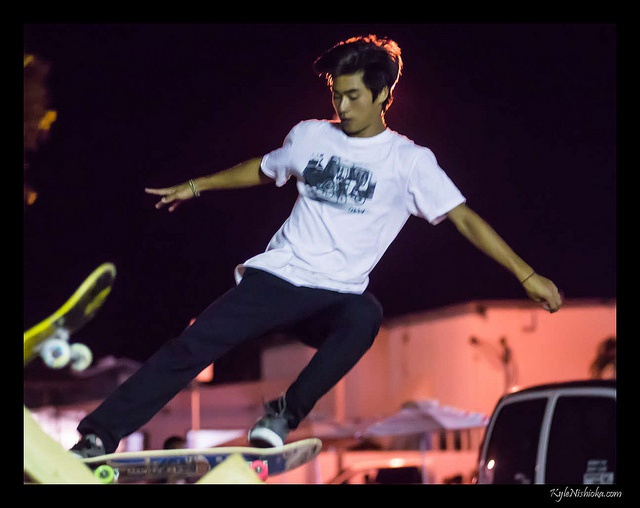Describe the objects in this image and their specific colors. I can see people in black, lavender, brown, and gray tones, car in black, gray, and maroon tones, skateboard in black, gray, darkgray, beige, and navy tones, skateboard in black, olive, gray, and darkgray tones, and umbrella in black, brown, gray, lightpink, and purple tones in this image. 